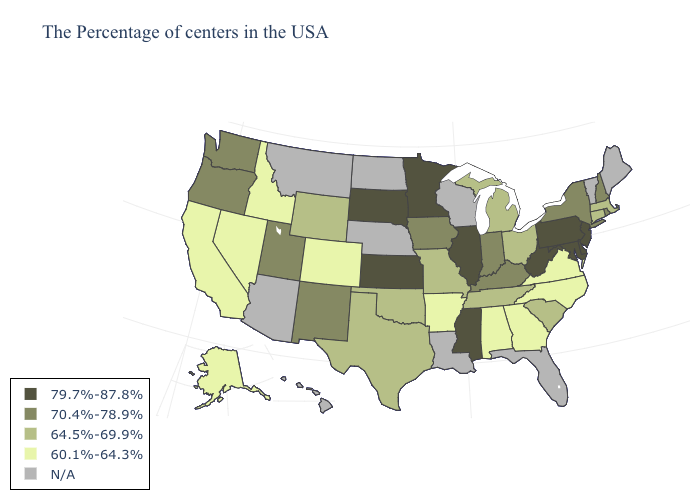What is the lowest value in states that border Nevada?
Quick response, please. 60.1%-64.3%. What is the value of North Carolina?
Quick response, please. 60.1%-64.3%. Name the states that have a value in the range 79.7%-87.8%?
Quick response, please. New Jersey, Delaware, Maryland, Pennsylvania, West Virginia, Illinois, Mississippi, Minnesota, Kansas, South Dakota. Does Mississippi have the highest value in the South?
Be succinct. Yes. Among the states that border Minnesota , does Iowa have the highest value?
Write a very short answer. No. Among the states that border Ohio , does Kentucky have the lowest value?
Be succinct. No. Name the states that have a value in the range 64.5%-69.9%?
Answer briefly. Massachusetts, Connecticut, South Carolina, Ohio, Michigan, Tennessee, Missouri, Oklahoma, Texas, Wyoming. What is the lowest value in the USA?
Concise answer only. 60.1%-64.3%. Does the first symbol in the legend represent the smallest category?
Answer briefly. No. What is the value of Hawaii?
Keep it brief. N/A. Among the states that border Pennsylvania , does Maryland have the lowest value?
Quick response, please. No. What is the lowest value in states that border Massachusetts?
Short answer required. 64.5%-69.9%. What is the highest value in the USA?
Answer briefly. 79.7%-87.8%. Among the states that border Mississippi , does Tennessee have the highest value?
Concise answer only. Yes. 